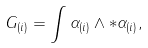<formula> <loc_0><loc_0><loc_500><loc_500>G _ { ( i ) } = \int \alpha _ { ( i ) } \wedge \ast \alpha _ { ( i ) } ,</formula> 